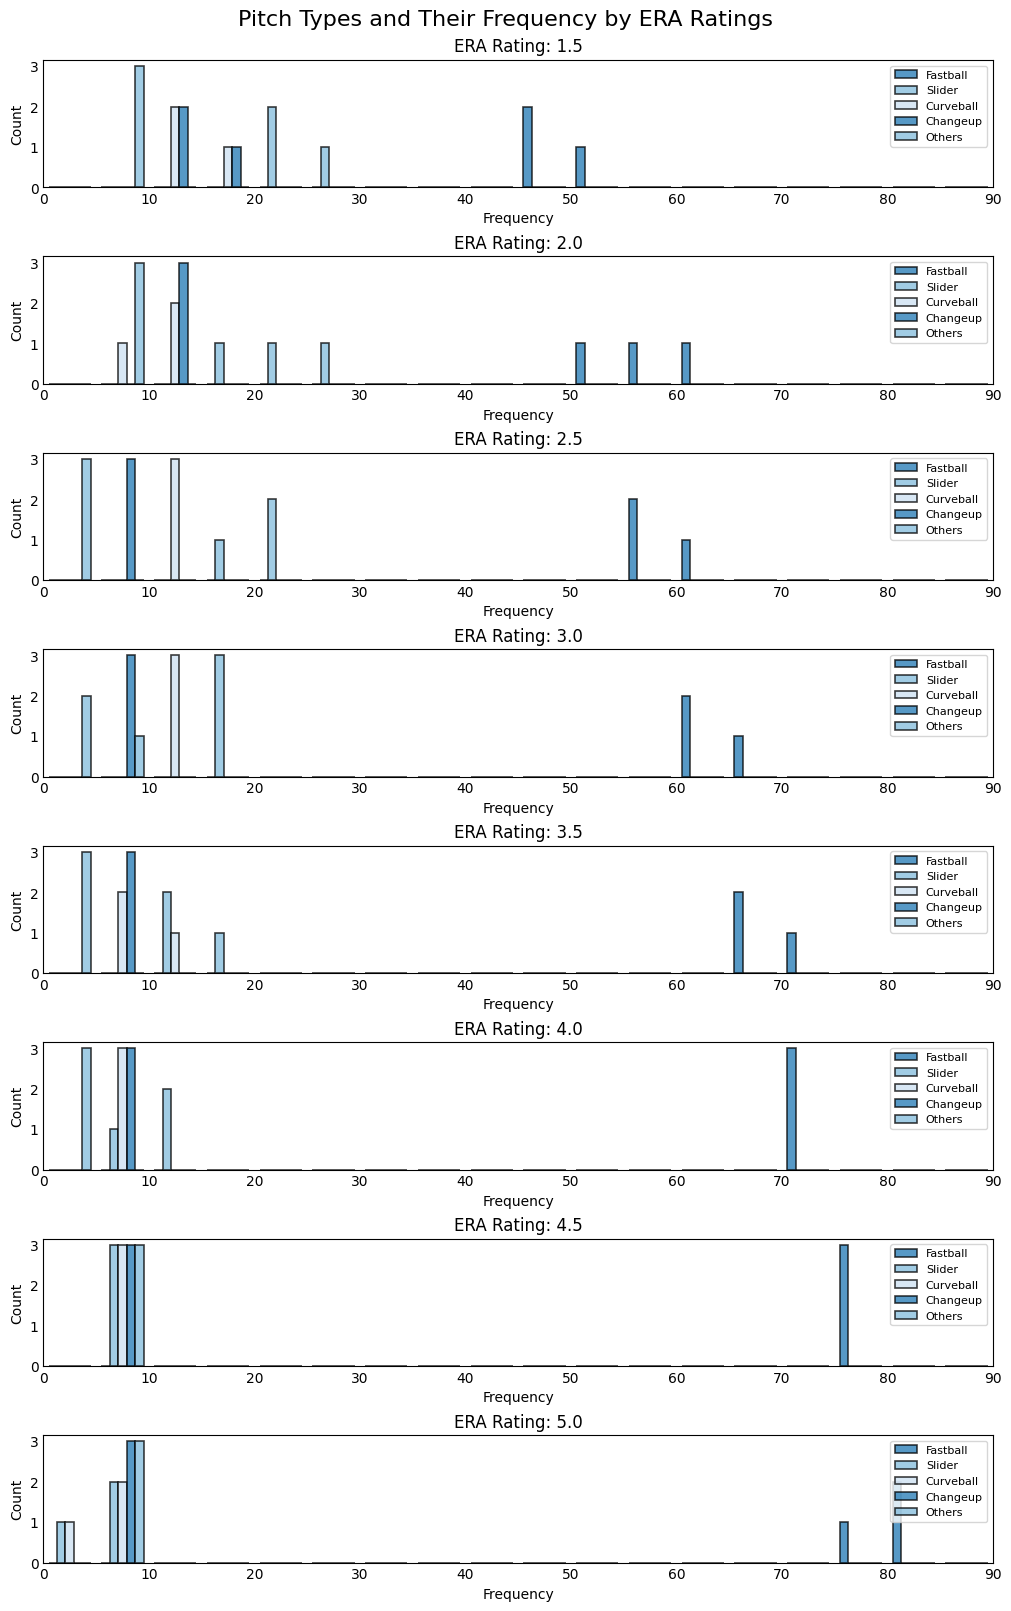Which pitch type has the highest average frequency for the ERA Rating of 2.0? In the plot for ERA Rating of 2.0, observe the height of the histograms for each pitch type. Fastball histograms consistently reach the highest, more frequently than other types, indicating it has the highest average frequency.
Answer: Fastball How does the frequency of sliders compare to the frequency of curveballs for an ERA Rating of 3.5? Look at the ERA Rating of 3.5 histogram. For Sliders, the bars are taller than those for Curveballs across the samples, indicating sliders are used more frequently.
Answer: Sliders more frequent Which ERA Rating shows the highest use of fastballs? Here, you need to compare the Fastball histogram across all ERA Ratings. The ERA Rating of 5.0 has the tallest Fastball bars, indicating the highest use.
Answer: 5.0 What is the average frequency of changeups for an ERA Rating of 1.5? Check the Changeup histograms for the 1.5 ERA Rating. The values are 10, 15, and 13. Adding these gives 38, and dividing by 3 gives an average of 12.7.
Answer: 12.7 Which ERA Rating has the most diverse distribution of pitch types? Evaluate the height variations within each ERA Rating's set of histograms. The ERA Rating of 1.5 shows considerable variation among all pitch types, indicating higher diversity.
Answer: 1.5 Do higher ERA Ratings correspond to a higher frequency of fastballs? Compare the Fastball histogram heights across the increasing ERA Ratings. As the ERA Ratings increase from 1.5 to 5.0, the Fastball frequency also increases, showing a correlation.
Answer: Yes What is the total count of sliders for ERA Rating 4.0? Check the Slider histograms for ERA Rating of 4.0: 10 + 8 + 12. Summing these values gives a total count of 30.
Answer: 30 What is the most frequently thrown pitch type for an ERA Rating of 4.5? In the plots for the ERA Rating of 4.5, the Fastball histograms are the tallest, indicating fastballs are the most frequently thrown.
Answer: Fastball 